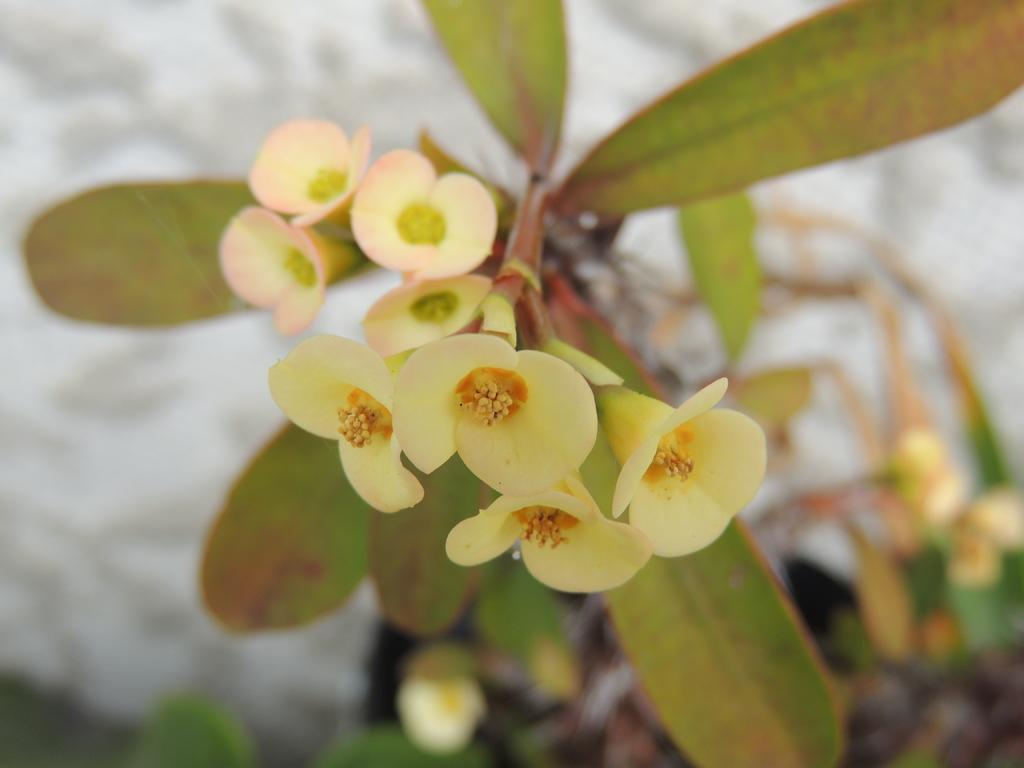What type of plant life is visible in the image? There are flowers and a plant in the image. What part of the plant is visible in the image? Leaves are visible in the image. What type of cannon is present in the image? There is no cannon present in the image; it features plant life. What type of motion can be observed in the image? There is no motion visible in the image; it is a still image of plant life. 